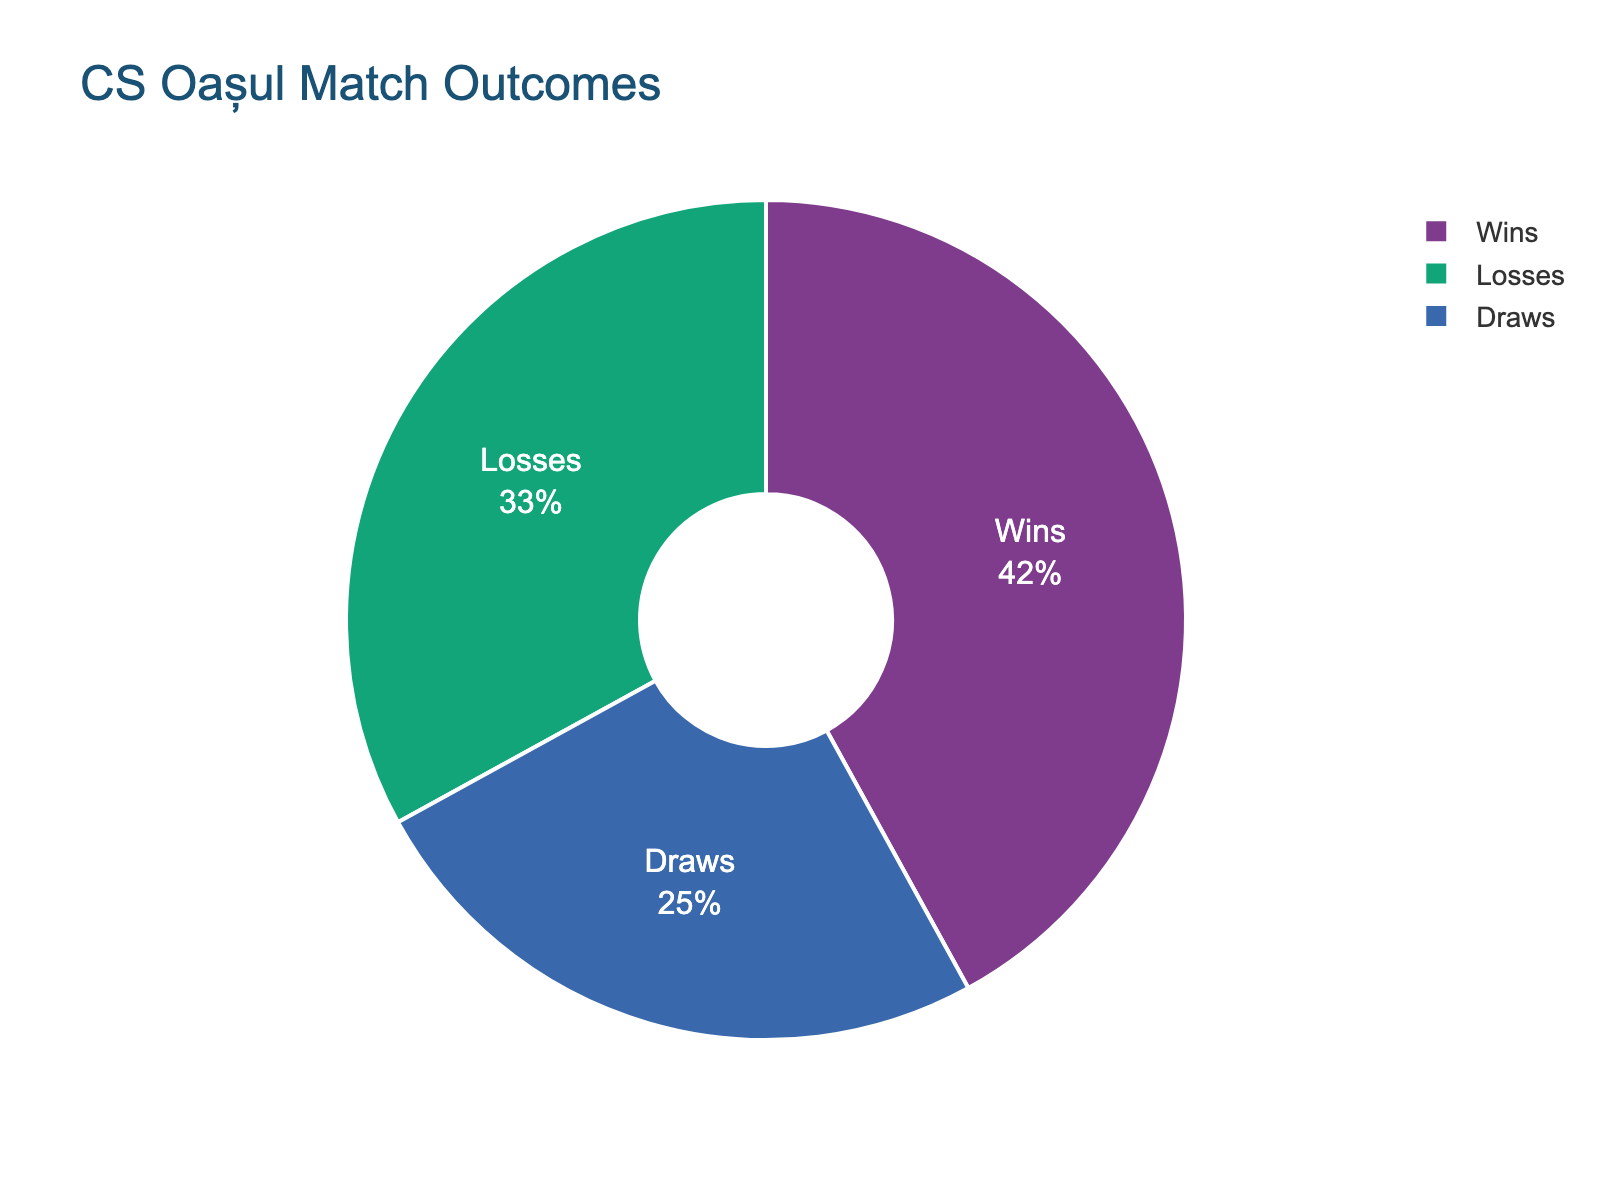What's the most common match outcome for CS Oașul this season? The figure shows a pie chart with sections for Wins, Losses, and Draws. The largest section represents Wins.
Answer: Wins How many more percentage points are there for Wins compared to Draws? Wins have 42%, and Draws have 25%. The difference is 42% - 25%.
Answer: 17% Which outcome is least frequent for CS Oașul this season? The pie chart shows three outcomes, with Draws having the smallest section.
Answer: Draws What percentage of the matches resulted in losses? The pie chart has a section labeled Losses, which constitutes 33%.
Answer: 33% Is the percentage of Wins greater than the sum of Losses and Draws? Wins are 42%. The sum of Losses (33%) and Draws (25%) is 58%. 42% is not greater than 58%.
Answer: No What is the ratio of Wins to the total matches not lost by CS Oașul? Wins are 42%, and Draws are 25%. The total non-lost matches are Wins + Draws = 42% + 25% = 67%. The ratio of Wins to non-lost matches is 42:67.
Answer: 42:67 What percentage of matches did not result in a win? Losses are 33%, and Draws are 25%. The percentage of non-win matches is Losses + Draws = 33% + 25%.
Answer: 58% Which color is used to represent Draws on the pie chart? The pie chart uses specific colors for each section. The Draws section is in green.
Answer: Green 